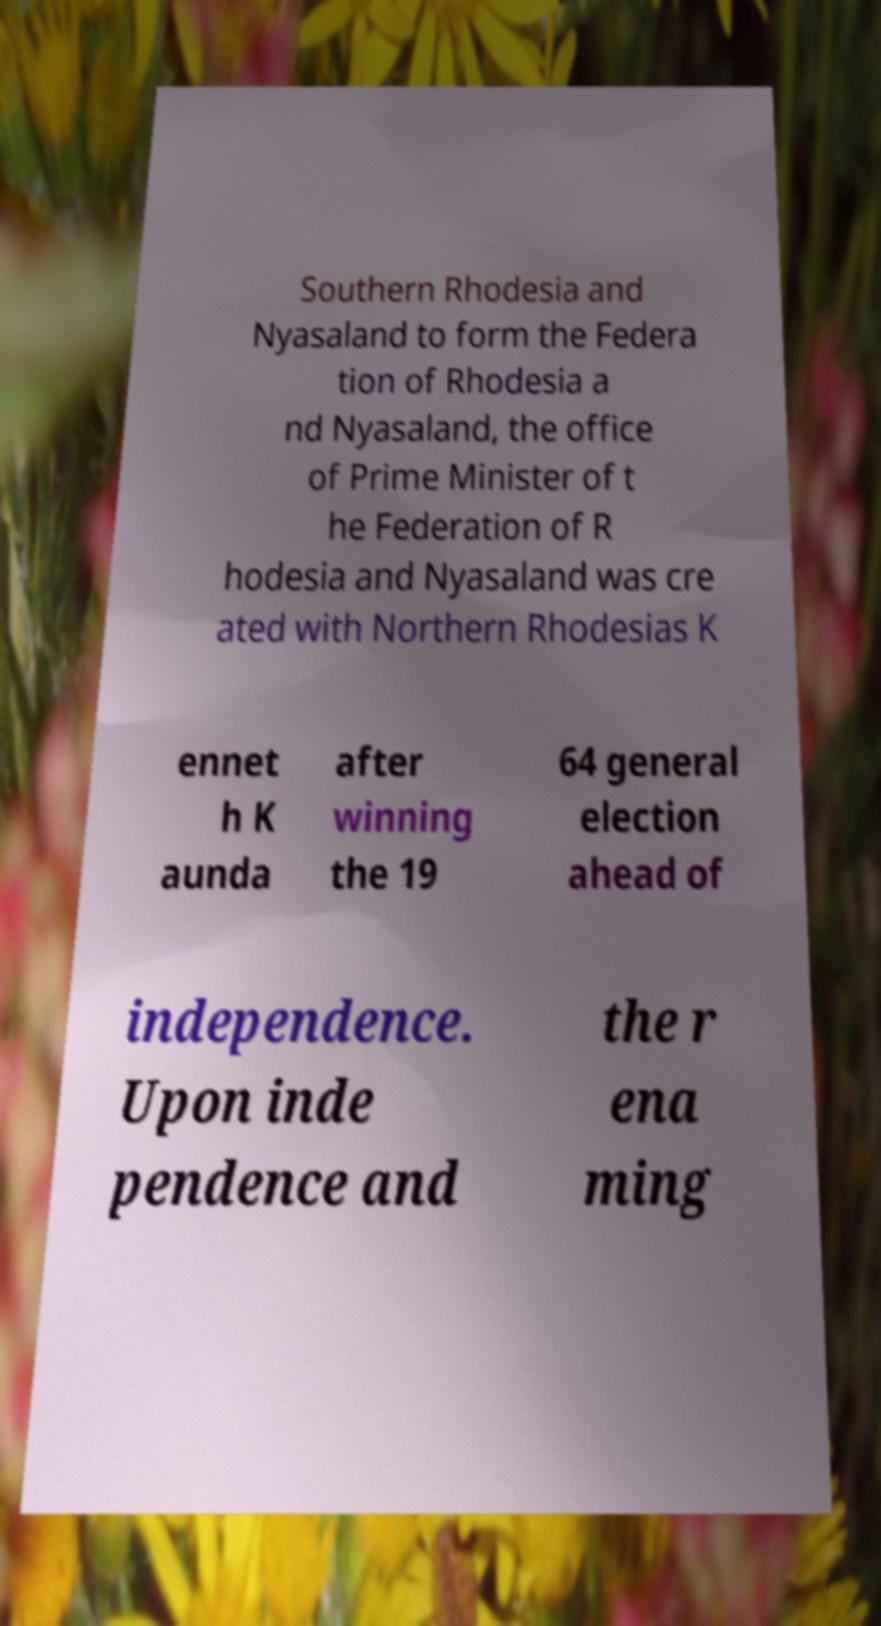For documentation purposes, I need the text within this image transcribed. Could you provide that? Southern Rhodesia and Nyasaland to form the Federa tion of Rhodesia a nd Nyasaland, the office of Prime Minister of t he Federation of R hodesia and Nyasaland was cre ated with Northern Rhodesias K ennet h K aunda after winning the 19 64 general election ahead of independence. Upon inde pendence and the r ena ming 